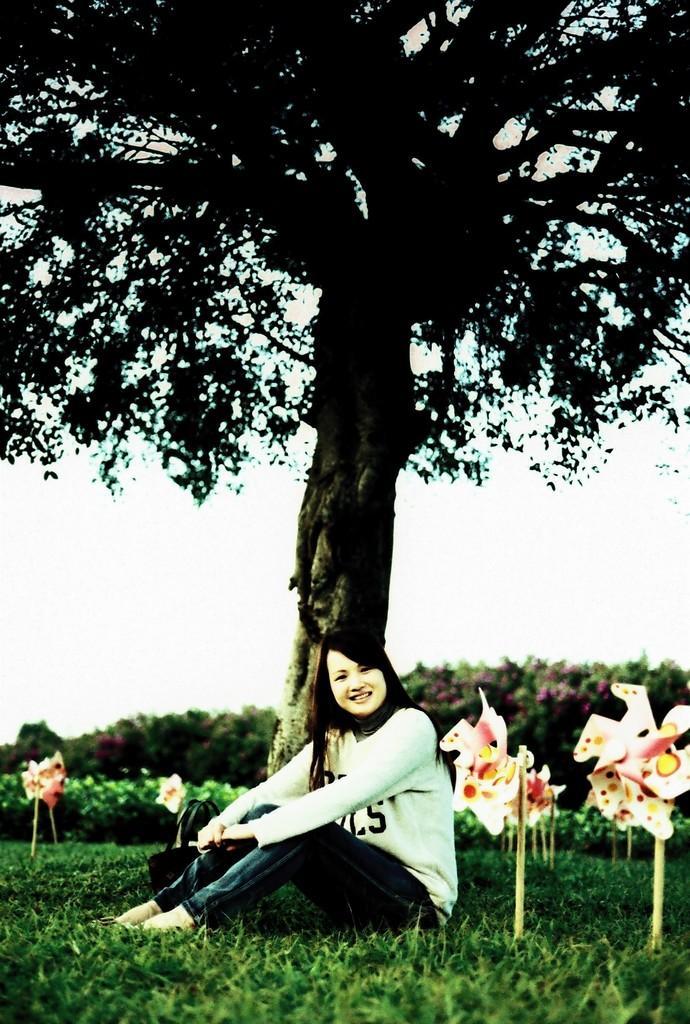Could you give a brief overview of what you see in this image? In this picture there is a girl wearing white color t-shirt sitting on the grass, smiling and giving a pose into the camera. Beside there are some flowers. In the background there is a huge tree. 